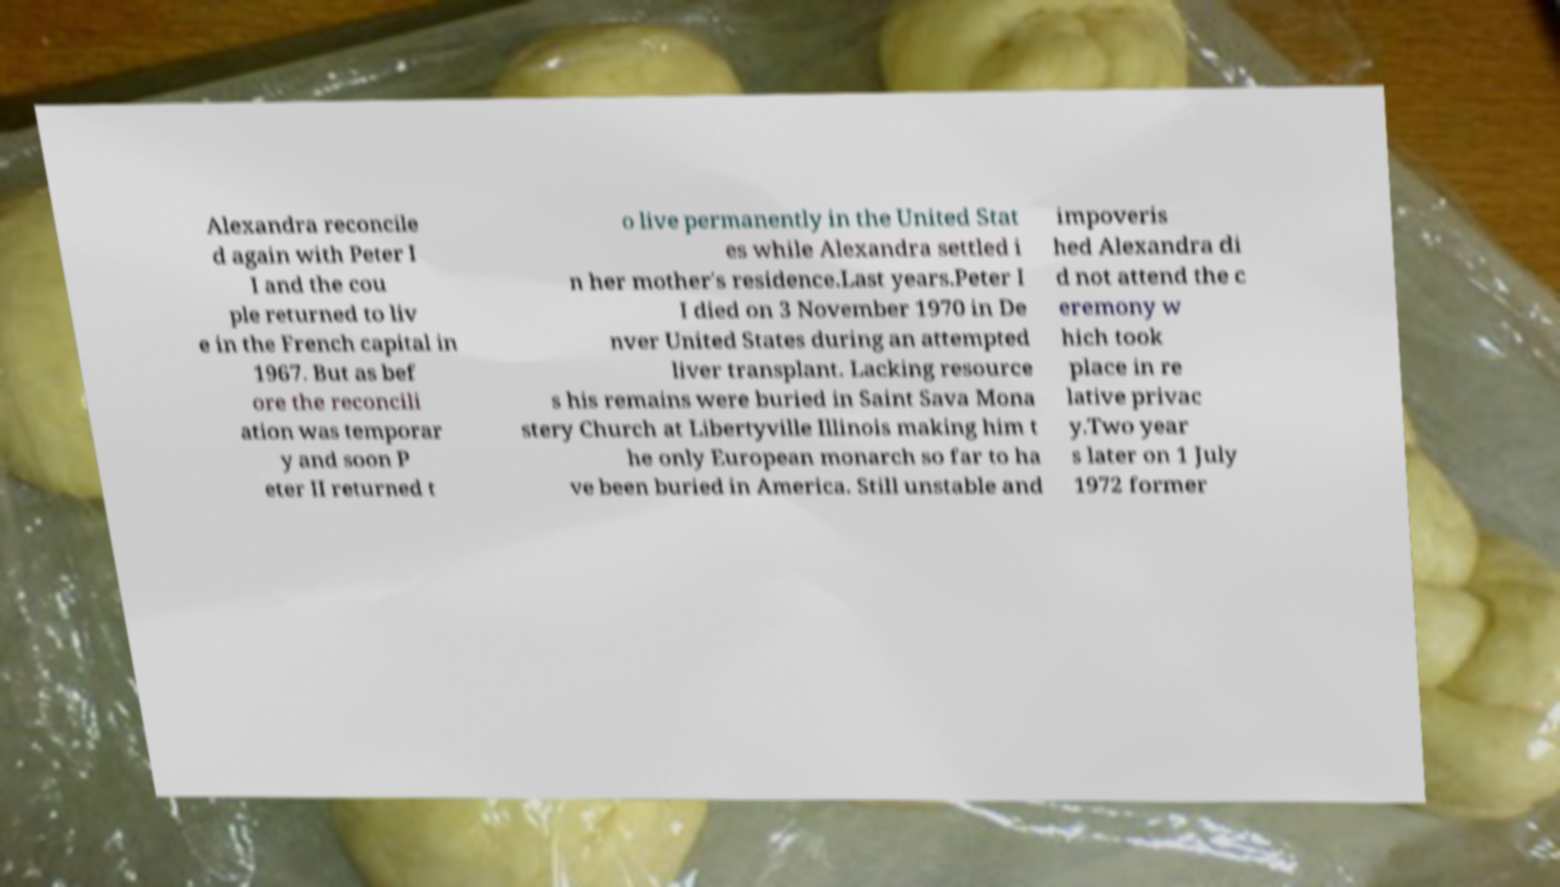Please identify and transcribe the text found in this image. Alexandra reconcile d again with Peter I I and the cou ple returned to liv e in the French capital in 1967. But as bef ore the reconcili ation was temporar y and soon P eter II returned t o live permanently in the United Stat es while Alexandra settled i n her mother's residence.Last years.Peter I I died on 3 November 1970 in De nver United States during an attempted liver transplant. Lacking resource s his remains were buried in Saint Sava Mona stery Church at Libertyville Illinois making him t he only European monarch so far to ha ve been buried in America. Still unstable and impoveris hed Alexandra di d not attend the c eremony w hich took place in re lative privac y.Two year s later on 1 July 1972 former 